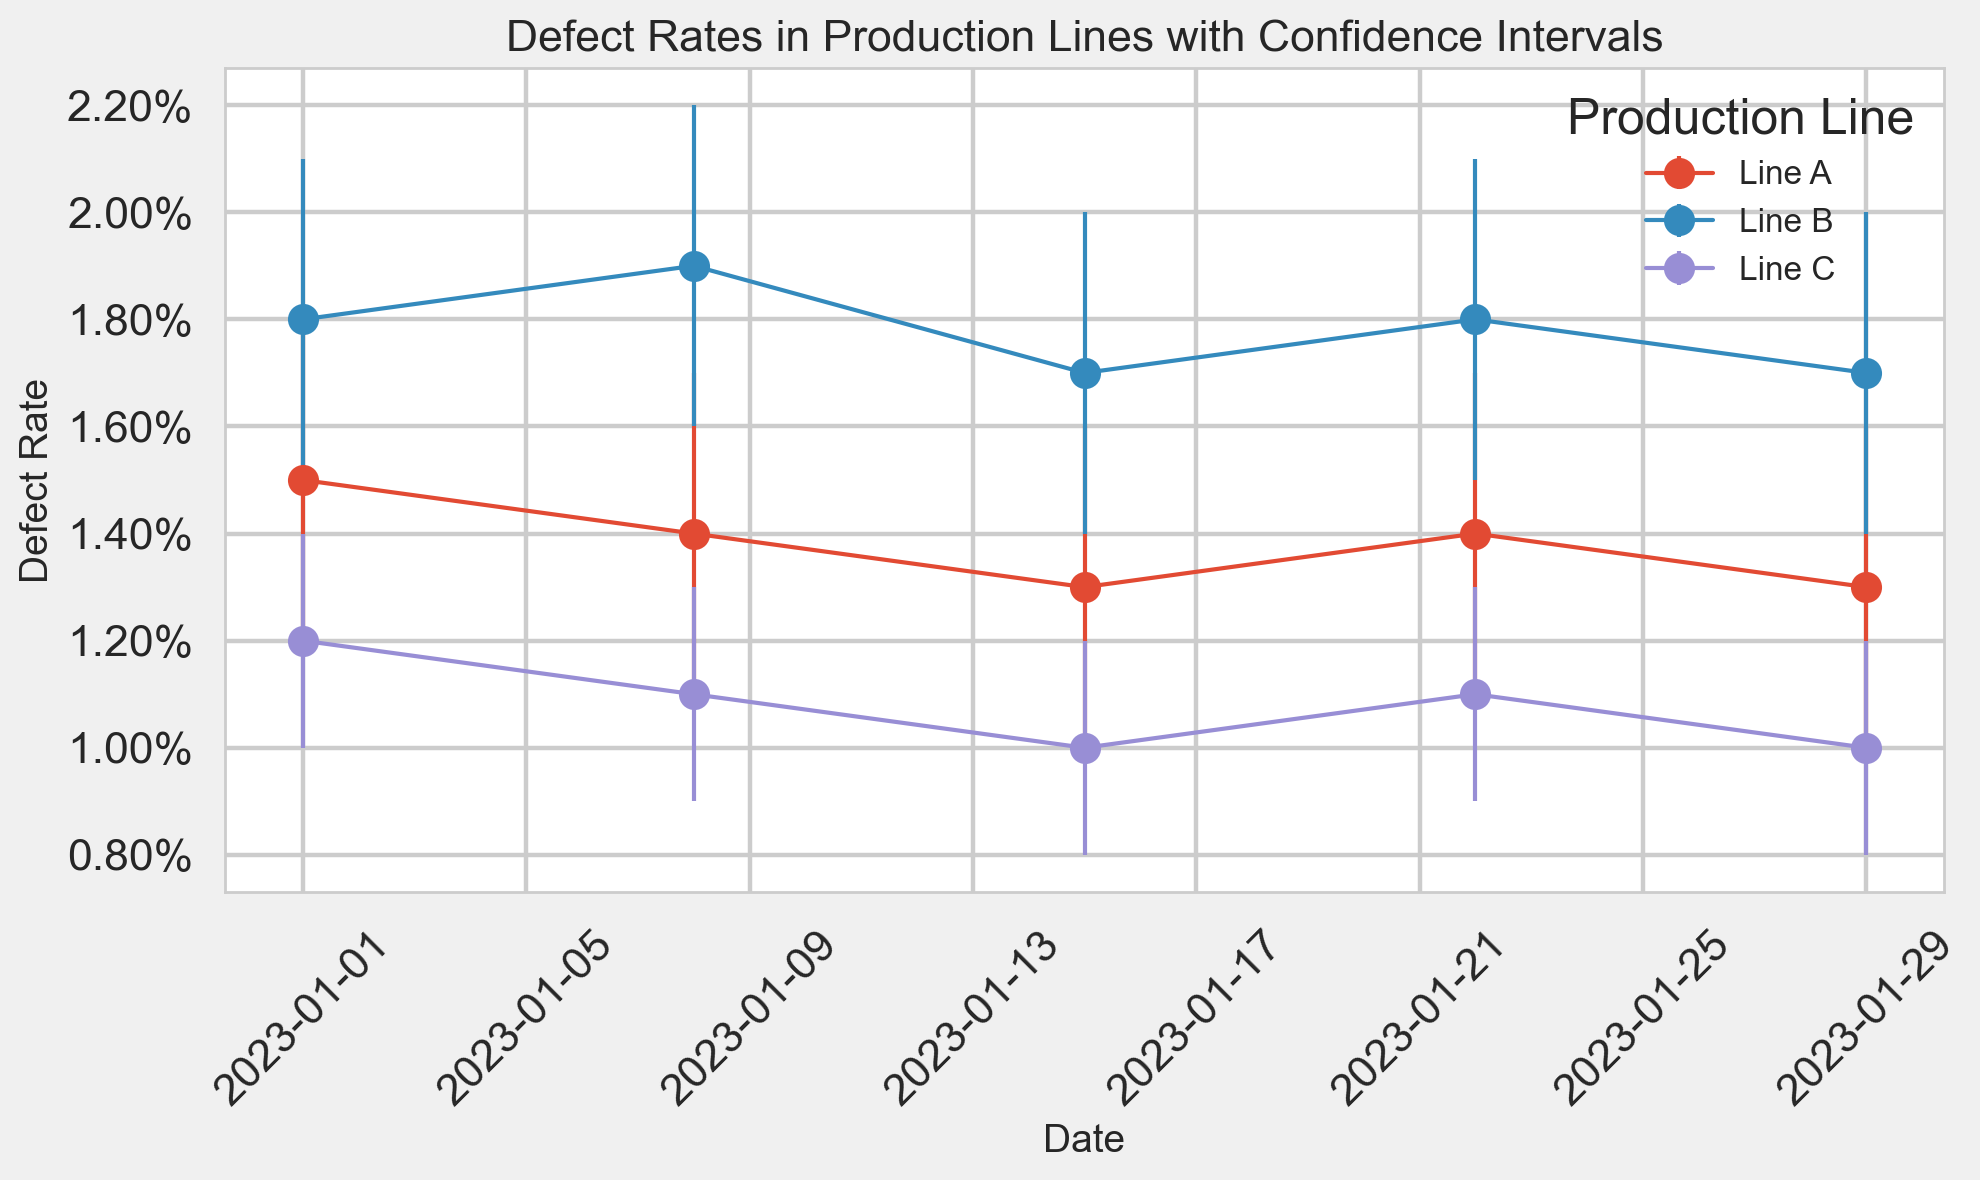Which production line had the lowest average defect rate in January 2023? Calculate the average defect rate for each production line. For Line A: (0.015 + 0.014 + 0.013 + 0.014 + 0.013) / 5 = 0.0138, for Line B: (0.018 + 0.019 + 0.017 + 0.018 + 0.017) / 5 = 0.0178, for Line C: (0.012 + 0.011 + 0.010 + 0.011 + 0.010) / 5 = 0.0108. Line C has the lowest average defect rate.
Answer: Line C On which date did Production Line B have the highest defect rate? Look at the defect rates for Production Line B and identify the highest value. The highest defect rate for Line B is 0.019 on 2023-01-08.
Answer: 2023-01-08 Which production line had the most consistent defect rate, judged by the confidence intervals? Compare the confidence intervals of defect rates for each production line. Line C has the narrowest confidence intervals on all dates, indicating it is the most consistent.
Answer: Line C How do the defect rates of Production Line A on 2023-01-01 and 2023-01-29 compare? Examine the defect rates for Line A on these two dates. On 2023-01-01, it is 0.015, and on 2023-01-29, it is 0.013, showing a decrease over time.
Answer: 0.015 was higher than 0.013 Between which production lines does the greatest difference in average defect rates occur? Calculate the differences in average defect rates between Lines A, B, and C. The differences are Line A - Line B: 0.0178 - 0.0138 = 0.004, Line A - Line C: 0.0138 - 0.0108 = 0.003, Line B - Line C: 0.0178 - 0.0108 = 0.007. The greatest difference is between Line B and Line C.
Answer: Line B and Line C What is the trend in defect rates over time for Production Line C? Look for trends in the defect rates for Line C. The defect rates decrease from 0.012 on 2023-01-01 to 0.010 on 2023-01-29, showing a downward trend.
Answer: Decreasing Are the confidence intervals for Production Line A overlapping with those of Production Line B on any date? Compare the confidence intervals of Lines A and B on each date to see if there are overlaps. None of the confidence intervals overlap on any date.
Answer: No Which production line showed the widest range in defect rates throughout January 2023? Calculate the range of defect rates for each line: 
Line A: 0.015 - 0.013 = 0.002 
Line B: 0.019 - 0.017 = 0.002 
Line C: 0.012 - 0.010 = 0.002 
All lines have the same range of defect rates.
Answer: All lines What is the overall defect rate trend for all production lines combined? Examine the general trend in defect rates for all lines over time. Generally, all lines show a stable or slightly decreasing trend in defect rates throughout January 2023.
Answer: Stable or slightly decreasing 